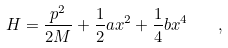<formula> <loc_0><loc_0><loc_500><loc_500>H = \frac { p ^ { 2 } } { 2 M } + \frac { 1 } { 2 } a x ^ { 2 } + \frac { 1 } { 4 } b x ^ { 4 } \quad ,</formula> 